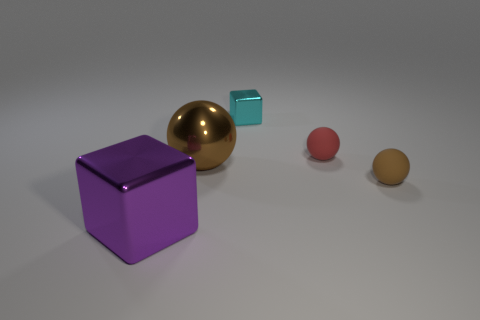Are the large purple thing and the small red thing made of the same material?
Provide a short and direct response. No. What number of yellow objects are either metal objects or large cubes?
Your answer should be compact. 0. Are there more brown rubber spheres that are behind the red rubber sphere than brown matte things?
Your response must be concise. No. Are there any shiny balls of the same color as the small cube?
Your response must be concise. No. How big is the cyan cube?
Your answer should be very brief. Small. Is the color of the small metallic thing the same as the metallic sphere?
Offer a terse response. No. How many objects are tiny yellow metal cylinders or metal blocks behind the small red object?
Offer a very short reply. 1. How many big purple metallic objects are in front of the metallic block in front of the tiny cyan cube to the left of the red rubber object?
Provide a short and direct response. 0. There is a tiny object that is the same color as the large shiny sphere; what is it made of?
Ensure brevity in your answer.  Rubber. How many green shiny cylinders are there?
Ensure brevity in your answer.  0. 